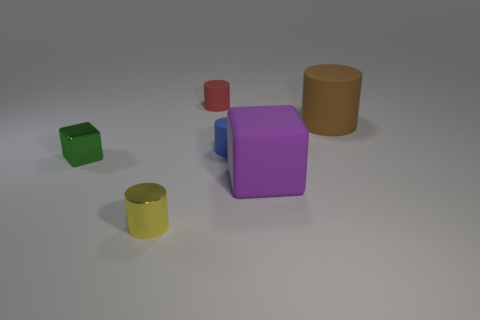What number of other objects are the same shape as the tiny blue rubber object?
Provide a succinct answer. 3. How many purple things are tiny balls or matte things?
Your answer should be very brief. 1. What is the shape of the tiny red object that is made of the same material as the big cylinder?
Your answer should be compact. Cylinder. The small cylinder that is both in front of the big cylinder and behind the yellow cylinder is what color?
Your answer should be compact. Blue. What size is the cube that is on the right side of the tiny matte object right of the red cylinder?
Offer a terse response. Large. Is the number of blue rubber objects to the left of the tiny green thing the same as the number of small blue matte things?
Make the answer very short. No. How many gray things are there?
Your answer should be compact. 0. What shape is the thing that is both to the right of the small blue object and on the left side of the large cylinder?
Your answer should be very brief. Cube. Is there a object that has the same material as the purple block?
Your answer should be very brief. Yes. Is the number of metallic objects to the left of the large purple cube the same as the number of tiny cylinders in front of the tiny red cylinder?
Your answer should be very brief. Yes. 